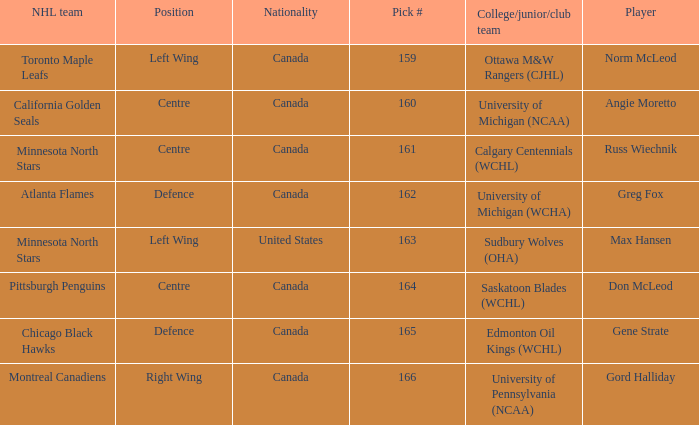What team did Russ Wiechnik, on the centre position, come from? Calgary Centennials (WCHL). Write the full table. {'header': ['NHL team', 'Position', 'Nationality', 'Pick #', 'College/junior/club team', 'Player'], 'rows': [['Toronto Maple Leafs', 'Left Wing', 'Canada', '159', 'Ottawa M&W Rangers (CJHL)', 'Norm McLeod'], ['California Golden Seals', 'Centre', 'Canada', '160', 'University of Michigan (NCAA)', 'Angie Moretto'], ['Minnesota North Stars', 'Centre', 'Canada', '161', 'Calgary Centennials (WCHL)', 'Russ Wiechnik'], ['Atlanta Flames', 'Defence', 'Canada', '162', 'University of Michigan (WCHA)', 'Greg Fox'], ['Minnesota North Stars', 'Left Wing', 'United States', '163', 'Sudbury Wolves (OHA)', 'Max Hansen'], ['Pittsburgh Penguins', 'Centre', 'Canada', '164', 'Saskatoon Blades (WCHL)', 'Don McLeod'], ['Chicago Black Hawks', 'Defence', 'Canada', '165', 'Edmonton Oil Kings (WCHL)', 'Gene Strate'], ['Montreal Canadiens', 'Right Wing', 'Canada', '166', 'University of Pennsylvania (NCAA)', 'Gord Halliday']]} 